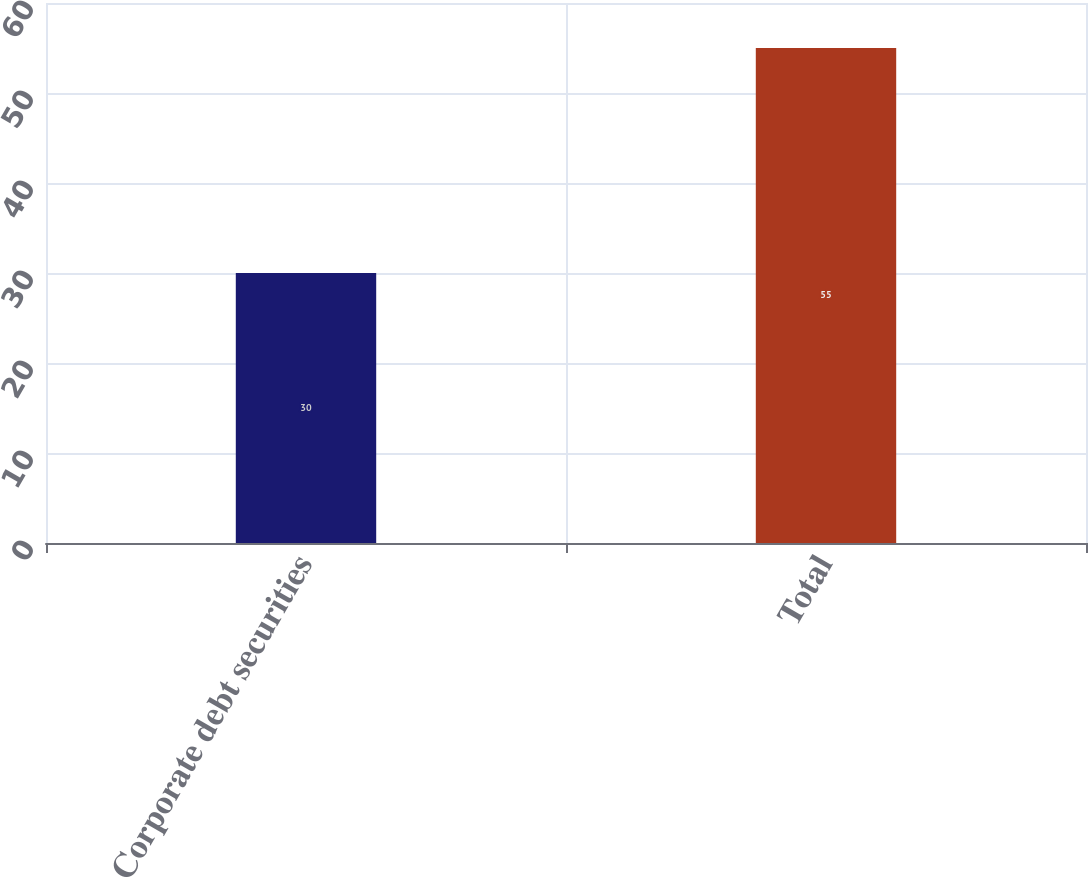<chart> <loc_0><loc_0><loc_500><loc_500><bar_chart><fcel>Corporate debt securities<fcel>Total<nl><fcel>30<fcel>55<nl></chart> 